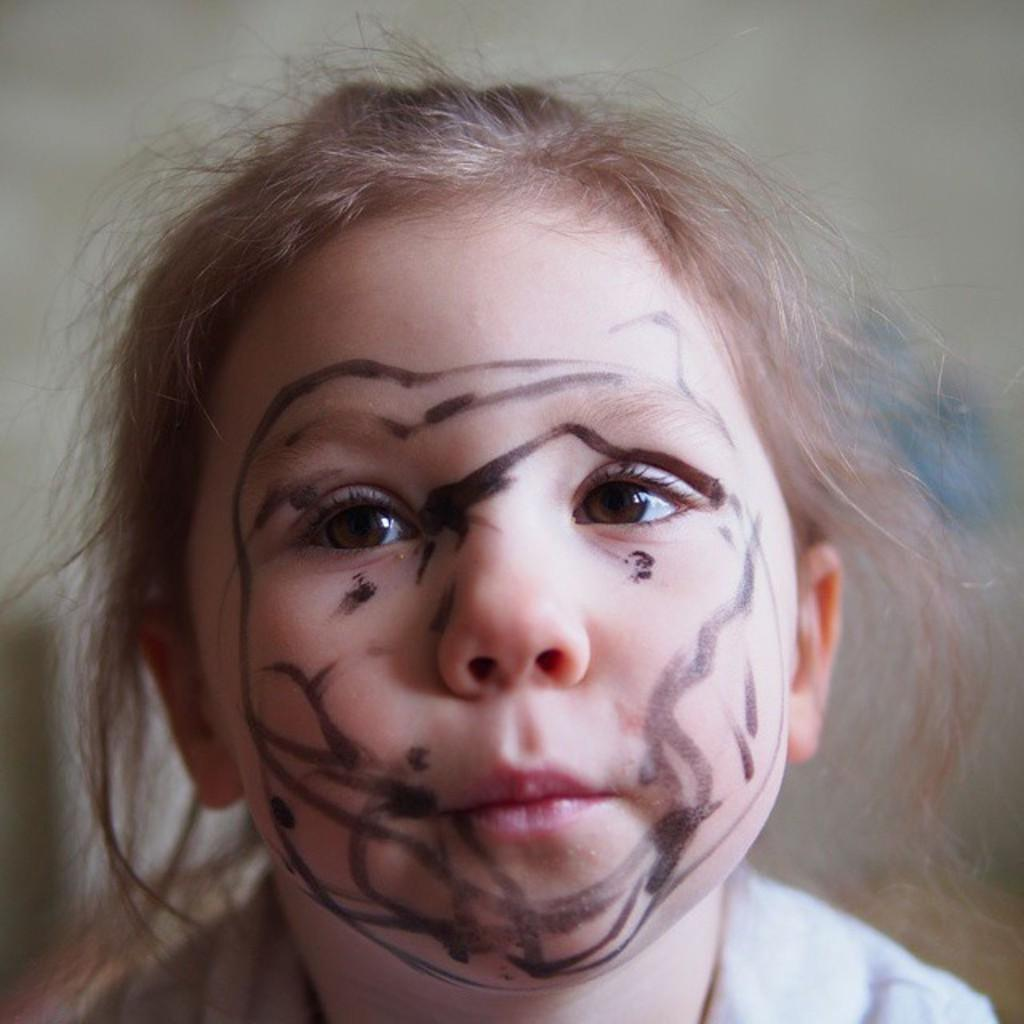Who is the main subject in the image? There is a girl in the image. What is on the girl's face? There is a painting on the girl's face. Can you describe the background of the image? The background of the image is blurry. What letters does the girl spell out with her hands in the image? There is no indication in the image that the girl is spelling out any letters with her hands. 